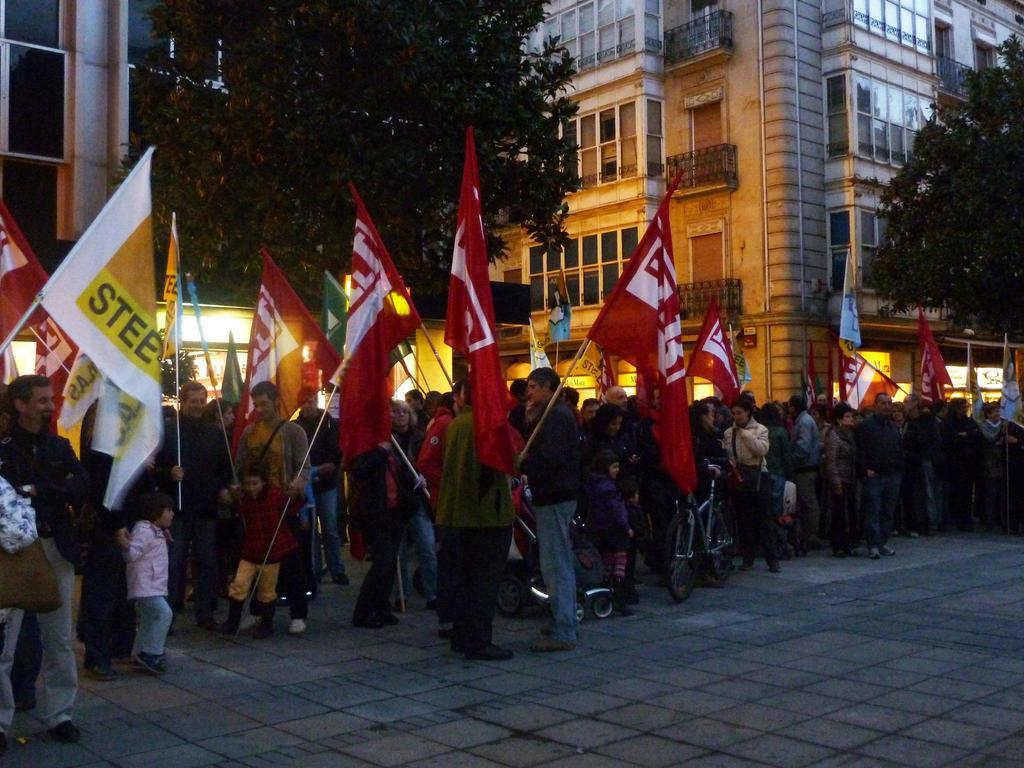What are the people in the middle of the image doing? The people in the middle of the image are standing and holding flags. What other objects can be seen in the image? There are bicycles in the image. What can be seen in the background of the image? There are trees and buildings in the background of the image. What type of hen can be seen in the image? There is no hen present in the image. What thoughts are the people holding flags having in the image? The image does not provide information about the thoughts of the people holding flags. 